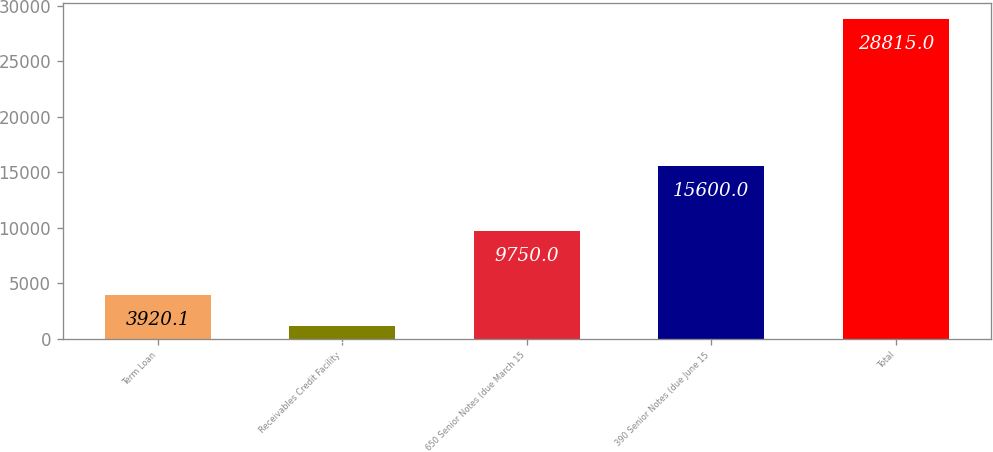<chart> <loc_0><loc_0><loc_500><loc_500><bar_chart><fcel>Term Loan<fcel>Receivables Credit Facility<fcel>650 Senior Notes (due March 15<fcel>390 Senior Notes (due June 15<fcel>Total<nl><fcel>3920.1<fcel>1154<fcel>9750<fcel>15600<fcel>28815<nl></chart> 